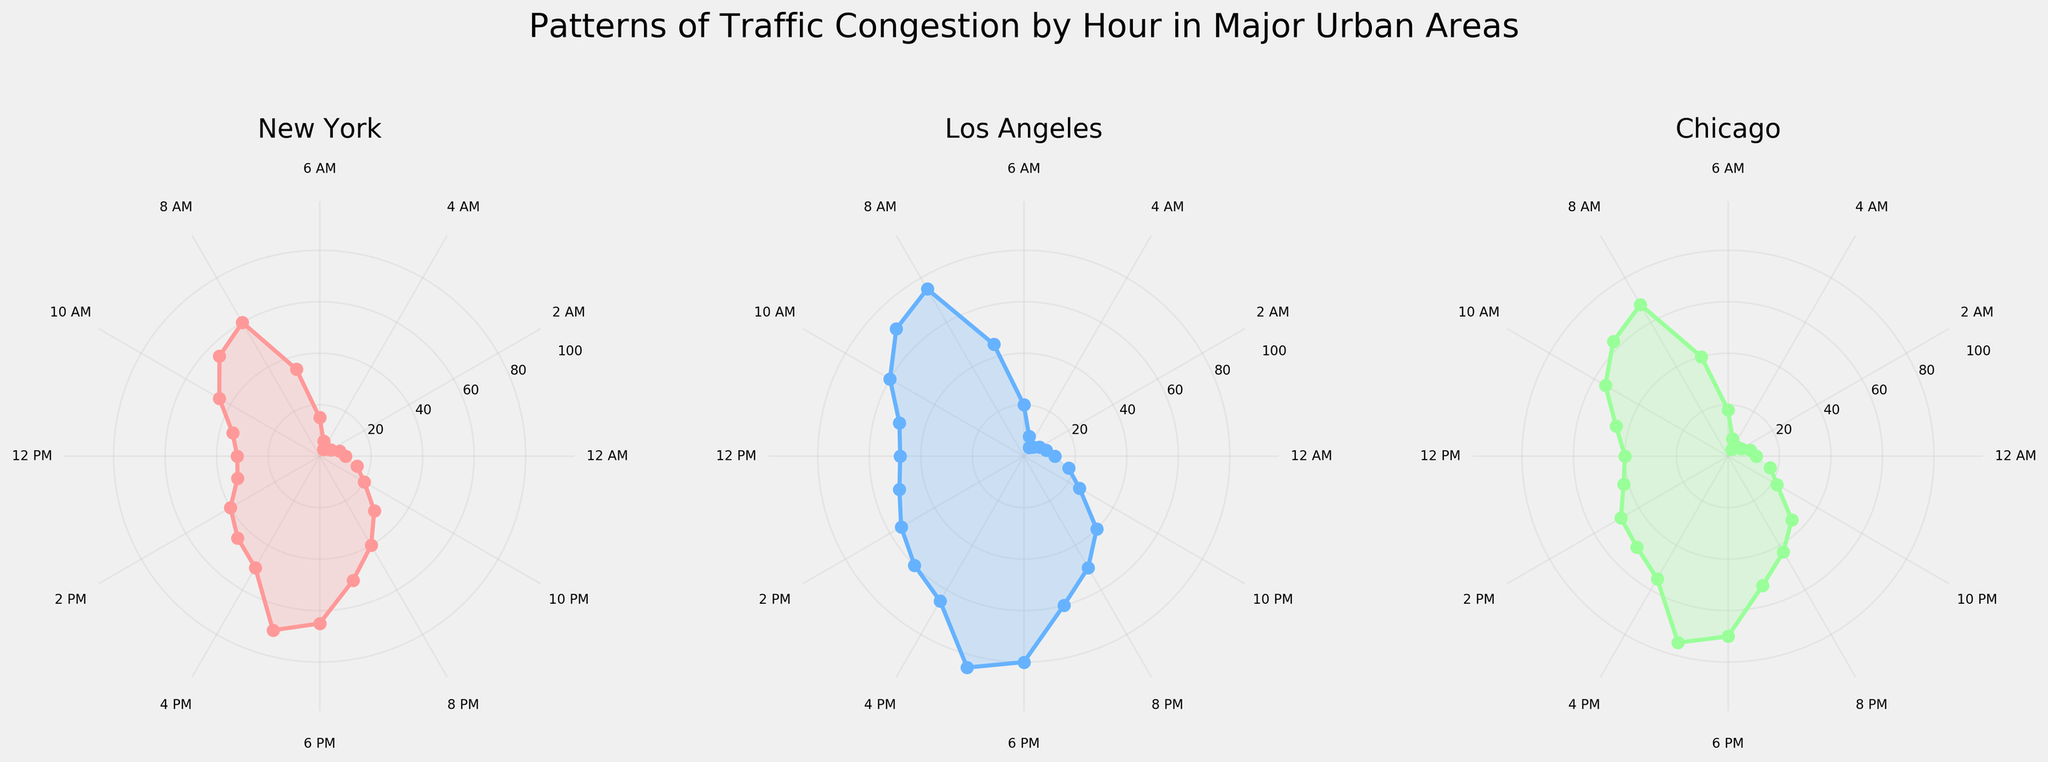what is the congestion level in New York at 8 AM? From the flower chart of New York, you can locate 8 AM on the outer circle's labels and follow the corresponding radial line to its intersection with the plotted line. The congestion level is represented by the radial distance from the center, which shows a considerable peak at 8 AM.
Answer: 60 which city experiences the highest congestion level at 5 PM? By examining the subplot for each city, you can identify the 5 PM point (17:00 label) and see the congestion levels for New York, Los Angeles, and Chicago. In Los Angeles, the congestion level peaks sharply higher than in New York and Chicago at the same time.
Answer: Los Angeles compare the congestion level between New York and Chicago at 9 AM. Locate the 9 AM points for both New York and Chicago on their respective charts. Follow the radial line to its intersection with the plotted line in each subplot. The radial distance indicates congestion levels, with New York at 55 and Chicago slightly higher at 63.
Answer: Chicago at what time does Los Angeles experience the lowest congestion? For Los Angeles, find the smallest radial distance from the center on its flower chart. The smallest value corresponds to a time around 4 AM, indicating the lowest congestion.
Answer: 4 AM which city shows a significant increase in congestion level between 7 AM and 8 AM? Check the congestion levels between 7 AM and 8 AM for each subplot. Only New York, with a sharp rise from 35 to 60, demonstrates a significant increase in congestion.
Answer: New York calculate the average congestion level in Chicago between 1 PM and 3 PM (inclusive). In Chicago's subplot, note the congestion levels at 1 PM (42), 2 PM (48), and 3 PM (50). Average these values: (42 + 48 + 50) / 3.
Answer: 46.67 which city experiences the highest congestion at midnight? Locate the 12 AM points for each city on their respective charts. Chicago has a congestion level of 11, New York has 10, and Los Angeles has 12, making Los Angeles the highest at this hour.
Answer: Los Angeles is the congestion level at 5 PM higher than 6 PM in New York? On the New York subplot, compare the congestion levels at 5 PM (70) and 6 PM (65). Since 70 is greater than 65, congestion at 5 PM is indeed higher.
Answer: Yes how does the congestion level at 10 PM in Los Angeles compare to the level at 10 AM in the same city? For Los Angeles, identify and compare the values at 10 PM (25) and 10 AM (60). The congestion at 10 PM is significantly lower.
Answer: Lower 